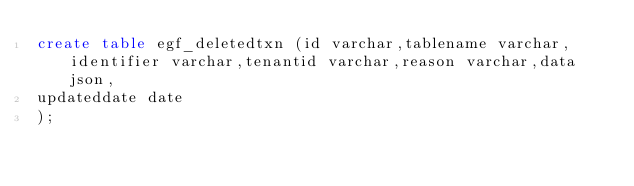<code> <loc_0><loc_0><loc_500><loc_500><_SQL_>create table egf_deletedtxn (id varchar,tablename varchar,identifier varchar,tenantid varchar,reason varchar,data json,
updateddate date
);</code> 